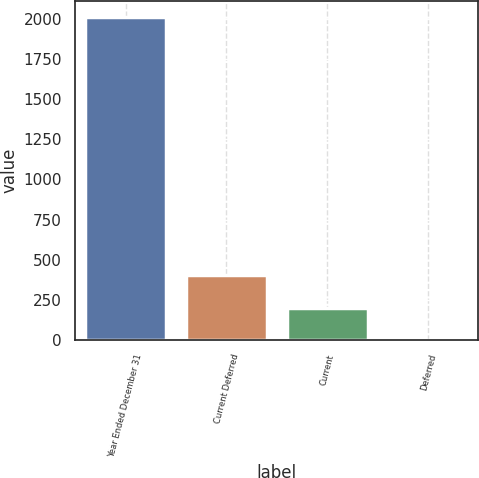<chart> <loc_0><loc_0><loc_500><loc_500><bar_chart><fcel>Year Ended December 31<fcel>Current Deferred<fcel>Current<fcel>Deferred<nl><fcel>2013<fcel>403.4<fcel>202.2<fcel>1<nl></chart> 